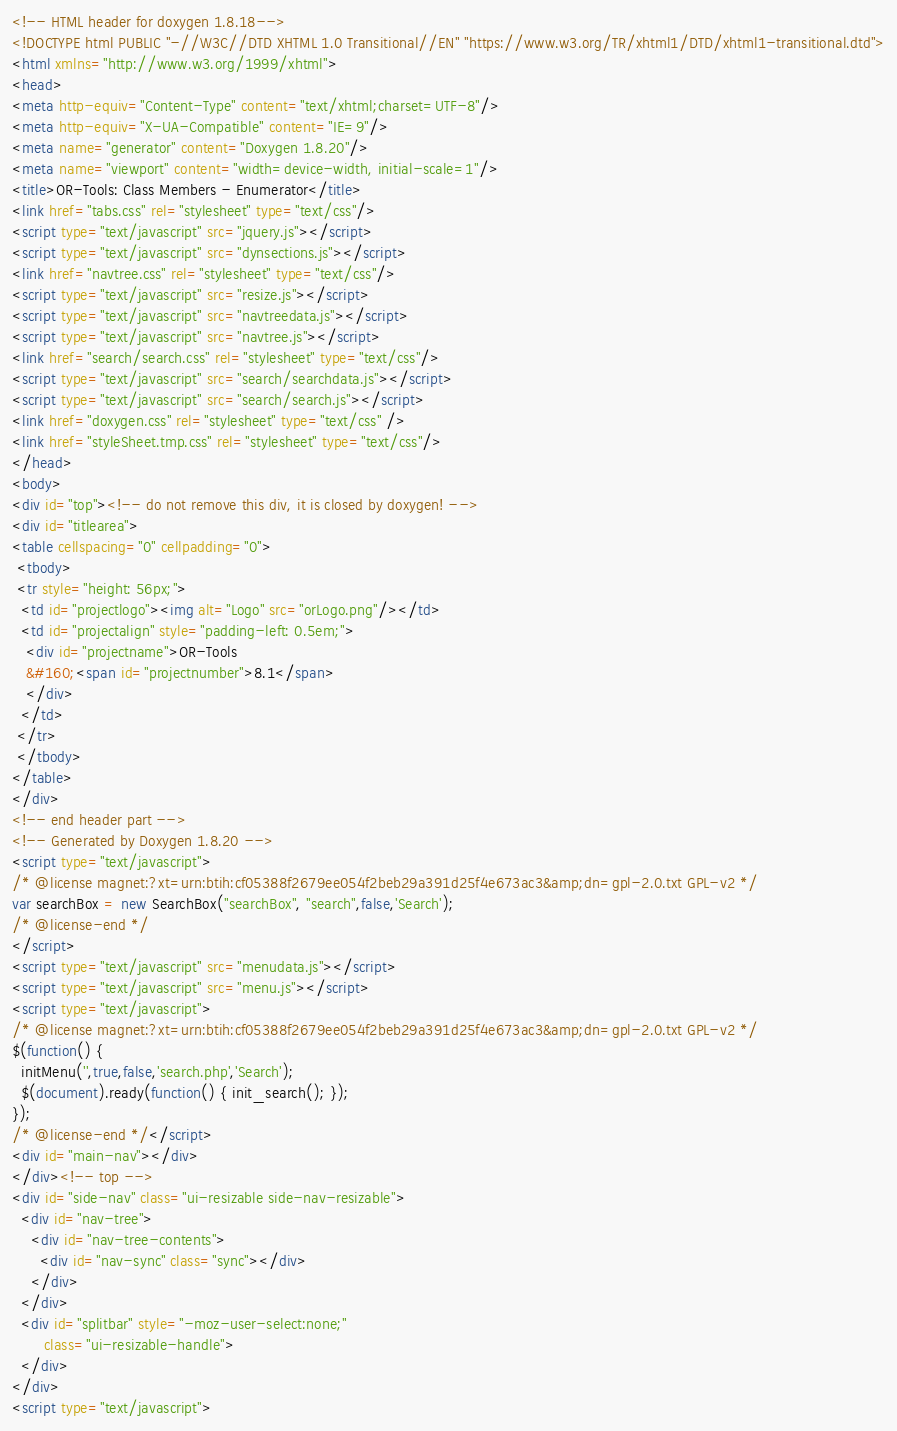<code> <loc_0><loc_0><loc_500><loc_500><_HTML_><!-- HTML header for doxygen 1.8.18-->
<!DOCTYPE html PUBLIC "-//W3C//DTD XHTML 1.0 Transitional//EN" "https://www.w3.org/TR/xhtml1/DTD/xhtml1-transitional.dtd">
<html xmlns="http://www.w3.org/1999/xhtml">
<head>
<meta http-equiv="Content-Type" content="text/xhtml;charset=UTF-8"/>
<meta http-equiv="X-UA-Compatible" content="IE=9"/>
<meta name="generator" content="Doxygen 1.8.20"/>
<meta name="viewport" content="width=device-width, initial-scale=1"/>
<title>OR-Tools: Class Members - Enumerator</title>
<link href="tabs.css" rel="stylesheet" type="text/css"/>
<script type="text/javascript" src="jquery.js"></script>
<script type="text/javascript" src="dynsections.js"></script>
<link href="navtree.css" rel="stylesheet" type="text/css"/>
<script type="text/javascript" src="resize.js"></script>
<script type="text/javascript" src="navtreedata.js"></script>
<script type="text/javascript" src="navtree.js"></script>
<link href="search/search.css" rel="stylesheet" type="text/css"/>
<script type="text/javascript" src="search/searchdata.js"></script>
<script type="text/javascript" src="search/search.js"></script>
<link href="doxygen.css" rel="stylesheet" type="text/css" />
<link href="styleSheet.tmp.css" rel="stylesheet" type="text/css"/>
</head>
<body>
<div id="top"><!-- do not remove this div, it is closed by doxygen! -->
<div id="titlearea">
<table cellspacing="0" cellpadding="0">
 <tbody>
 <tr style="height: 56px;">
  <td id="projectlogo"><img alt="Logo" src="orLogo.png"/></td>
  <td id="projectalign" style="padding-left: 0.5em;">
   <div id="projectname">OR-Tools
   &#160;<span id="projectnumber">8.1</span>
   </div>
  </td>
 </tr>
 </tbody>
</table>
</div>
<!-- end header part -->
<!-- Generated by Doxygen 1.8.20 -->
<script type="text/javascript">
/* @license magnet:?xt=urn:btih:cf05388f2679ee054f2beb29a391d25f4e673ac3&amp;dn=gpl-2.0.txt GPL-v2 */
var searchBox = new SearchBox("searchBox", "search",false,'Search');
/* @license-end */
</script>
<script type="text/javascript" src="menudata.js"></script>
<script type="text/javascript" src="menu.js"></script>
<script type="text/javascript">
/* @license magnet:?xt=urn:btih:cf05388f2679ee054f2beb29a391d25f4e673ac3&amp;dn=gpl-2.0.txt GPL-v2 */
$(function() {
  initMenu('',true,false,'search.php','Search');
  $(document).ready(function() { init_search(); });
});
/* @license-end */</script>
<div id="main-nav"></div>
</div><!-- top -->
<div id="side-nav" class="ui-resizable side-nav-resizable">
  <div id="nav-tree">
    <div id="nav-tree-contents">
      <div id="nav-sync" class="sync"></div>
    </div>
  </div>
  <div id="splitbar" style="-moz-user-select:none;" 
       class="ui-resizable-handle">
  </div>
</div>
<script type="text/javascript"></code> 